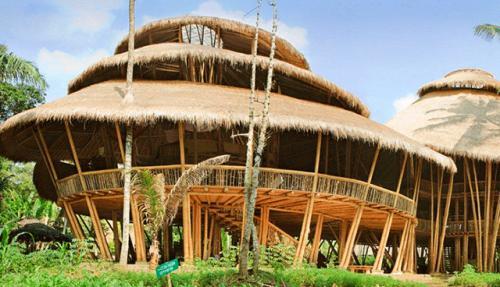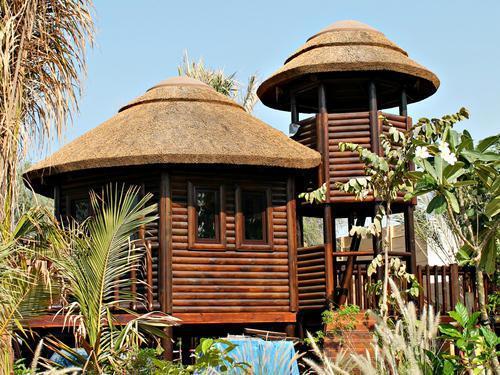The first image is the image on the left, the second image is the image on the right. Assess this claim about the two images: "In at least one image there is a rounded small gazebo with no more than five wooden poles and is not walled up.". Correct or not? Answer yes or no. No. The first image is the image on the left, the second image is the image on the right. Examine the images to the left and right. Is the description "The combined images include a two-story structure with wood rails on it and multiple tiered round thatched roofs." accurate? Answer yes or no. Yes. 